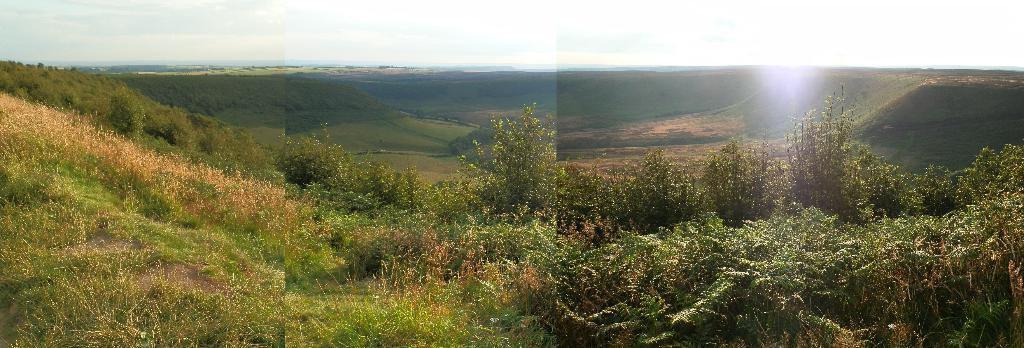What type of vegetation can be seen in the image? There are trees in the image. What is the color of the trees in the image? The trees are green in color. What other type of vegetation is present in the image? There is green grass and dry grass in the image. What is the color of the sky in the image? The sky appears to be white in color. How many girls are teaching in the image? There are no girls or any teaching activity present in the image. 